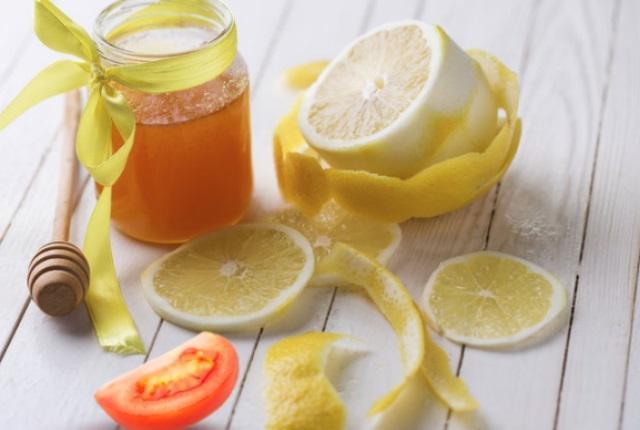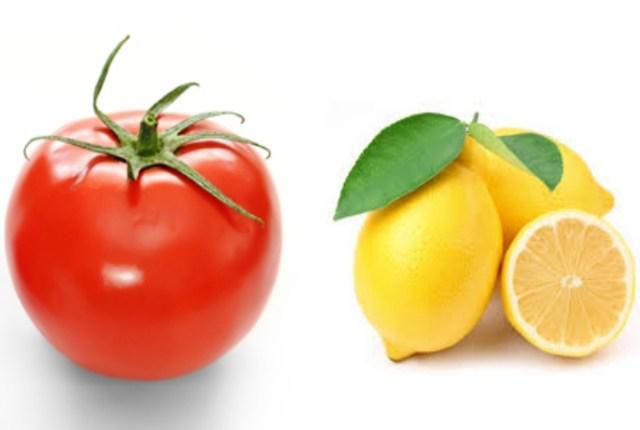The first image is the image on the left, the second image is the image on the right. Examine the images to the left and right. Is the description "An image without a beverage in a glass contains a whole tomato, whole lemons with green leaf, and a half lemon." accurate? Answer yes or no. Yes. The first image is the image on the left, the second image is the image on the right. Examine the images to the left and right. Is the description "In the left image, there are the same number of lemons and tomatoes." accurate? Answer yes or no. No. 